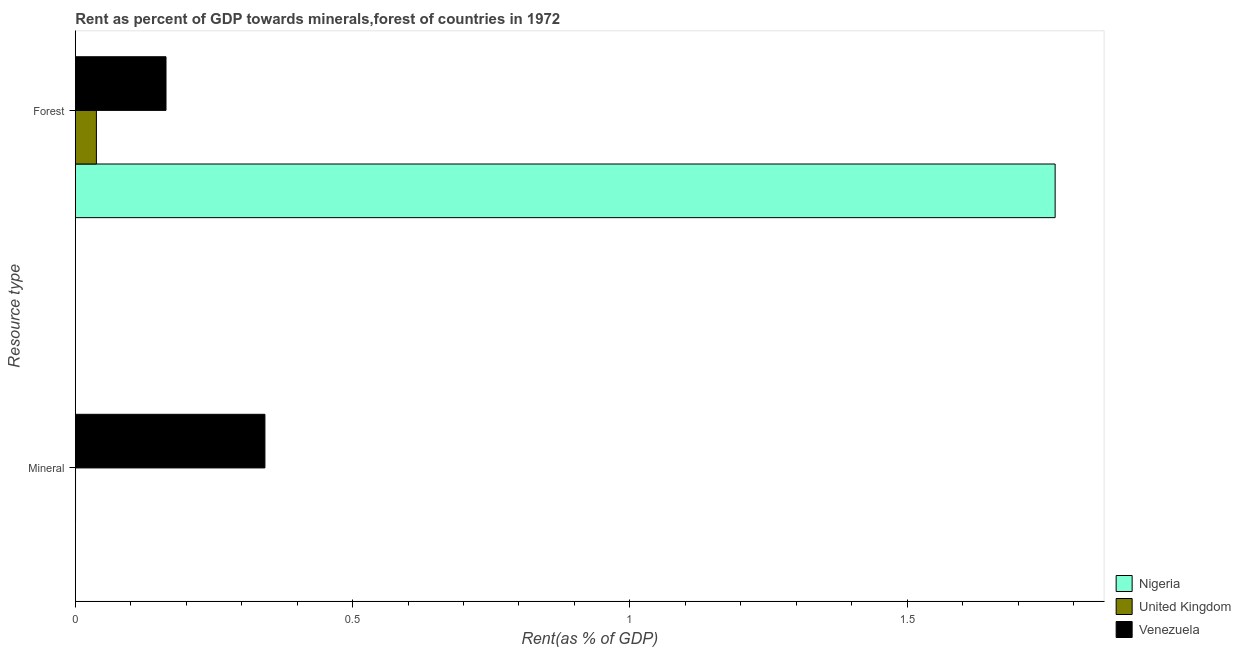Are the number of bars on each tick of the Y-axis equal?
Your response must be concise. Yes. What is the label of the 1st group of bars from the top?
Offer a very short reply. Forest. What is the forest rent in United Kingdom?
Offer a terse response. 0.04. Across all countries, what is the maximum mineral rent?
Offer a very short reply. 0.34. Across all countries, what is the minimum mineral rent?
Offer a terse response. 0. In which country was the mineral rent maximum?
Provide a succinct answer. Venezuela. In which country was the mineral rent minimum?
Provide a succinct answer. Nigeria. What is the total mineral rent in the graph?
Ensure brevity in your answer.  0.34. What is the difference between the mineral rent in United Kingdom and that in Venezuela?
Provide a short and direct response. -0.34. What is the difference between the forest rent in Venezuela and the mineral rent in United Kingdom?
Make the answer very short. 0.16. What is the average forest rent per country?
Your response must be concise. 0.66. What is the difference between the mineral rent and forest rent in Venezuela?
Make the answer very short. 0.18. What is the ratio of the forest rent in Nigeria to that in Venezuela?
Offer a very short reply. 10.8. What does the 2nd bar from the top in Forest represents?
Ensure brevity in your answer.  United Kingdom. What does the 3rd bar from the bottom in Forest represents?
Offer a very short reply. Venezuela. Are all the bars in the graph horizontal?
Give a very brief answer. Yes. How many countries are there in the graph?
Ensure brevity in your answer.  3. What is the difference between two consecutive major ticks on the X-axis?
Offer a very short reply. 0.5. Does the graph contain any zero values?
Make the answer very short. No. Where does the legend appear in the graph?
Your answer should be very brief. Bottom right. What is the title of the graph?
Your answer should be very brief. Rent as percent of GDP towards minerals,forest of countries in 1972. What is the label or title of the X-axis?
Your response must be concise. Rent(as % of GDP). What is the label or title of the Y-axis?
Your answer should be compact. Resource type. What is the Rent(as % of GDP) in Nigeria in Mineral?
Offer a terse response. 0. What is the Rent(as % of GDP) of United Kingdom in Mineral?
Your answer should be very brief. 0. What is the Rent(as % of GDP) of Venezuela in Mineral?
Provide a short and direct response. 0.34. What is the Rent(as % of GDP) of Nigeria in Forest?
Provide a succinct answer. 1.77. What is the Rent(as % of GDP) in United Kingdom in Forest?
Give a very brief answer. 0.04. What is the Rent(as % of GDP) of Venezuela in Forest?
Provide a short and direct response. 0.16. Across all Resource type, what is the maximum Rent(as % of GDP) in Nigeria?
Give a very brief answer. 1.77. Across all Resource type, what is the maximum Rent(as % of GDP) in United Kingdom?
Your answer should be compact. 0.04. Across all Resource type, what is the maximum Rent(as % of GDP) in Venezuela?
Give a very brief answer. 0.34. Across all Resource type, what is the minimum Rent(as % of GDP) in Nigeria?
Provide a succinct answer. 0. Across all Resource type, what is the minimum Rent(as % of GDP) in United Kingdom?
Provide a succinct answer. 0. Across all Resource type, what is the minimum Rent(as % of GDP) of Venezuela?
Provide a short and direct response. 0.16. What is the total Rent(as % of GDP) in Nigeria in the graph?
Your answer should be very brief. 1.77. What is the total Rent(as % of GDP) of United Kingdom in the graph?
Offer a very short reply. 0.04. What is the total Rent(as % of GDP) in Venezuela in the graph?
Give a very brief answer. 0.51. What is the difference between the Rent(as % of GDP) of Nigeria in Mineral and that in Forest?
Give a very brief answer. -1.77. What is the difference between the Rent(as % of GDP) in United Kingdom in Mineral and that in Forest?
Provide a short and direct response. -0.04. What is the difference between the Rent(as % of GDP) of Venezuela in Mineral and that in Forest?
Your answer should be very brief. 0.18. What is the difference between the Rent(as % of GDP) in Nigeria in Mineral and the Rent(as % of GDP) in United Kingdom in Forest?
Your answer should be compact. -0.04. What is the difference between the Rent(as % of GDP) of Nigeria in Mineral and the Rent(as % of GDP) of Venezuela in Forest?
Your answer should be compact. -0.16. What is the difference between the Rent(as % of GDP) of United Kingdom in Mineral and the Rent(as % of GDP) of Venezuela in Forest?
Give a very brief answer. -0.16. What is the average Rent(as % of GDP) of Nigeria per Resource type?
Give a very brief answer. 0.88. What is the average Rent(as % of GDP) of United Kingdom per Resource type?
Your answer should be compact. 0.02. What is the average Rent(as % of GDP) in Venezuela per Resource type?
Offer a terse response. 0.25. What is the difference between the Rent(as % of GDP) in Nigeria and Rent(as % of GDP) in United Kingdom in Mineral?
Offer a terse response. -0. What is the difference between the Rent(as % of GDP) in Nigeria and Rent(as % of GDP) in Venezuela in Mineral?
Provide a succinct answer. -0.34. What is the difference between the Rent(as % of GDP) of United Kingdom and Rent(as % of GDP) of Venezuela in Mineral?
Your answer should be compact. -0.34. What is the difference between the Rent(as % of GDP) of Nigeria and Rent(as % of GDP) of United Kingdom in Forest?
Keep it short and to the point. 1.73. What is the difference between the Rent(as % of GDP) of Nigeria and Rent(as % of GDP) of Venezuela in Forest?
Give a very brief answer. 1.6. What is the difference between the Rent(as % of GDP) in United Kingdom and Rent(as % of GDP) in Venezuela in Forest?
Give a very brief answer. -0.13. What is the ratio of the Rent(as % of GDP) of United Kingdom in Mineral to that in Forest?
Give a very brief answer. 0.01. What is the ratio of the Rent(as % of GDP) of Venezuela in Mineral to that in Forest?
Ensure brevity in your answer.  2.09. What is the difference between the highest and the second highest Rent(as % of GDP) of Nigeria?
Ensure brevity in your answer.  1.77. What is the difference between the highest and the second highest Rent(as % of GDP) in United Kingdom?
Provide a succinct answer. 0.04. What is the difference between the highest and the second highest Rent(as % of GDP) of Venezuela?
Offer a terse response. 0.18. What is the difference between the highest and the lowest Rent(as % of GDP) of Nigeria?
Your answer should be very brief. 1.77. What is the difference between the highest and the lowest Rent(as % of GDP) in United Kingdom?
Ensure brevity in your answer.  0.04. What is the difference between the highest and the lowest Rent(as % of GDP) of Venezuela?
Provide a short and direct response. 0.18. 